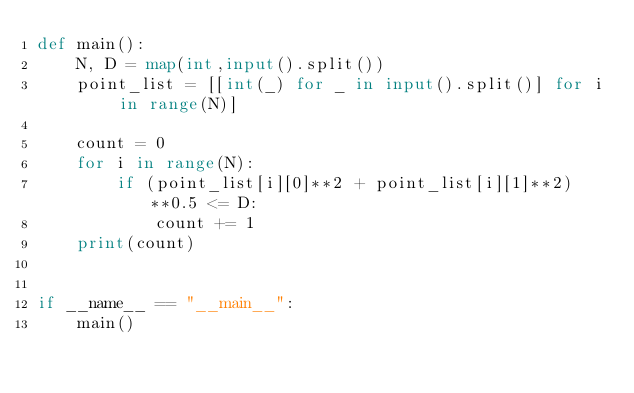<code> <loc_0><loc_0><loc_500><loc_500><_Python_>def main():
    N, D = map(int,input().split())
    point_list = [[int(_) for _ in input().split()] for i in range(N)]

    count = 0
    for i in range(N):
        if (point_list[i][0]**2 + point_list[i][1]**2)**0.5 <= D:
            count += 1
    print(count)


if __name__ == "__main__":
    main()</code> 